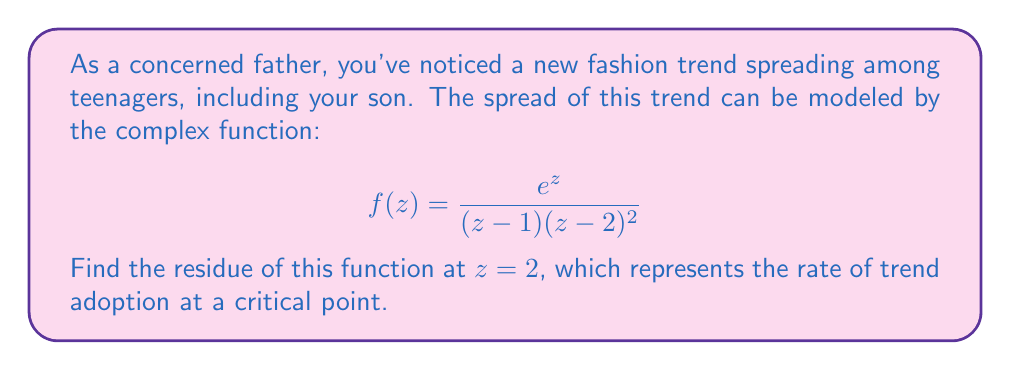Help me with this question. To find the residue of $f(z)$ at $z=2$, we need to analyze the function's behavior around this point. The function has a pole of order 2 at $z=2$.

For a pole of order 2, we can use the formula:

$$\text{Res}(f,2) = \lim_{z \to 2} \frac{d}{dz}\left[(z-2)^2 f(z)\right]$$

Let's follow these steps:

1) First, we simplify $(z-2)^2 f(z)$:

   $$(z-2)^2 f(z) = (z-2)^2 \cdot \frac{e^z}{(z-1)(z-2)^2} = \frac{e^z}{z-1}$$

2) Now we need to differentiate this with respect to $z$:

   $$\frac{d}{dz}\left[\frac{e^z}{z-1}\right] = \frac{e^z(z-1) - e^z}{(z-1)^2} = \frac{e^z z - e^z}{(z-1)^2}$$

3) Finally, we take the limit as $z$ approaches 2:

   $$\lim_{z \to 2} \frac{e^z z - e^z}{(z-1)^2} = \frac{e^2 \cdot 2 - e^2}{(2-1)^2} = \frac{e^2}{1} = e^2$$

This result represents the rate at which the trend is being adopted at the critical point, which could be useful in understanding how quickly your son and his peers might be influenced by this new fashion trend.
Answer: $e^2$ 